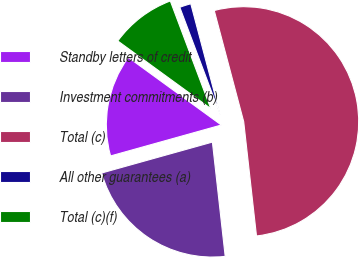Convert chart to OTSL. <chart><loc_0><loc_0><loc_500><loc_500><pie_chart><fcel>Standby letters of credit<fcel>Investment commitments (b)<fcel>Total (c)<fcel>All other guarantees (a)<fcel>Total (c)(f)<nl><fcel>14.34%<fcel>22.44%<fcel>52.35%<fcel>1.6%<fcel>9.27%<nl></chart> 